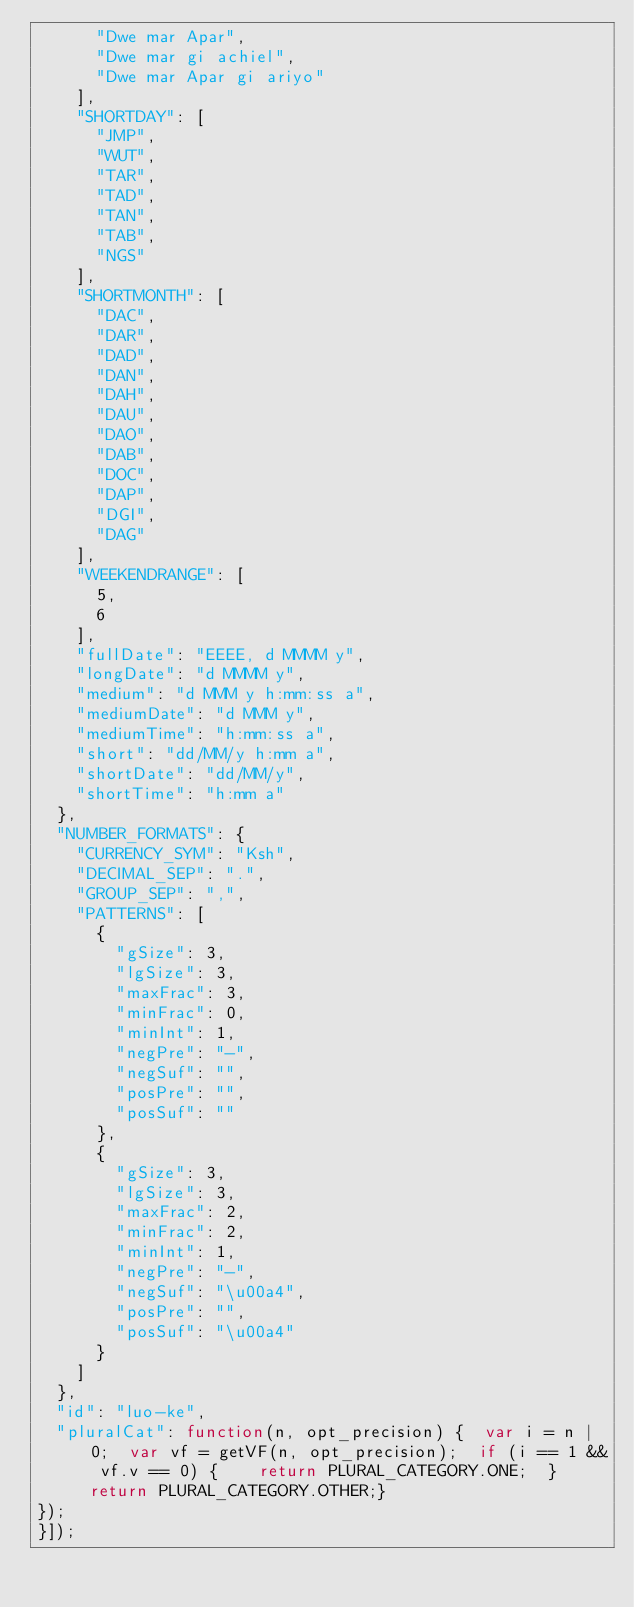<code> <loc_0><loc_0><loc_500><loc_500><_JavaScript_>      "Dwe mar Apar",
      "Dwe mar gi achiel",
      "Dwe mar Apar gi ariyo"
    ],
    "SHORTDAY": [
      "JMP",
      "WUT",
      "TAR",
      "TAD",
      "TAN",
      "TAB",
      "NGS"
    ],
    "SHORTMONTH": [
      "DAC",
      "DAR",
      "DAD",
      "DAN",
      "DAH",
      "DAU",
      "DAO",
      "DAB",
      "DOC",
      "DAP",
      "DGI",
      "DAG"
    ],
    "WEEKENDRANGE": [
      5,
      6
    ],
    "fullDate": "EEEE, d MMMM y",
    "longDate": "d MMMM y",
    "medium": "d MMM y h:mm:ss a",
    "mediumDate": "d MMM y",
    "mediumTime": "h:mm:ss a",
    "short": "dd/MM/y h:mm a",
    "shortDate": "dd/MM/y",
    "shortTime": "h:mm a"
  },
  "NUMBER_FORMATS": {
    "CURRENCY_SYM": "Ksh",
    "DECIMAL_SEP": ".",
    "GROUP_SEP": ",",
    "PATTERNS": [
      {
        "gSize": 3,
        "lgSize": 3,
        "maxFrac": 3,
        "minFrac": 0,
        "minInt": 1,
        "negPre": "-",
        "negSuf": "",
        "posPre": "",
        "posSuf": ""
      },
      {
        "gSize": 3,
        "lgSize": 3,
        "maxFrac": 2,
        "minFrac": 2,
        "minInt": 1,
        "negPre": "-",
        "negSuf": "\u00a4",
        "posPre": "",
        "posSuf": "\u00a4"
      }
    ]
  },
  "id": "luo-ke",
  "pluralCat": function(n, opt_precision) {  var i = n | 0;  var vf = getVF(n, opt_precision);  if (i == 1 && vf.v == 0) {    return PLURAL_CATEGORY.ONE;  }  return PLURAL_CATEGORY.OTHER;}
});
}]);
</code> 